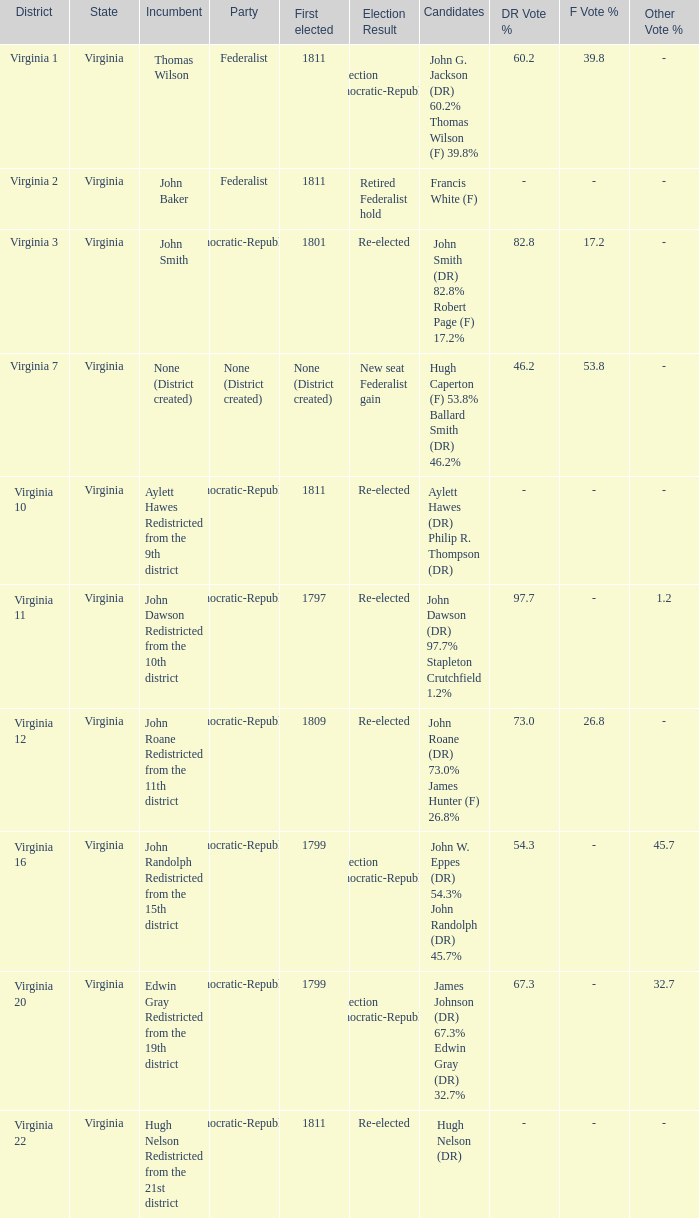Name the party for virginia 12 Democratic-Republican. 